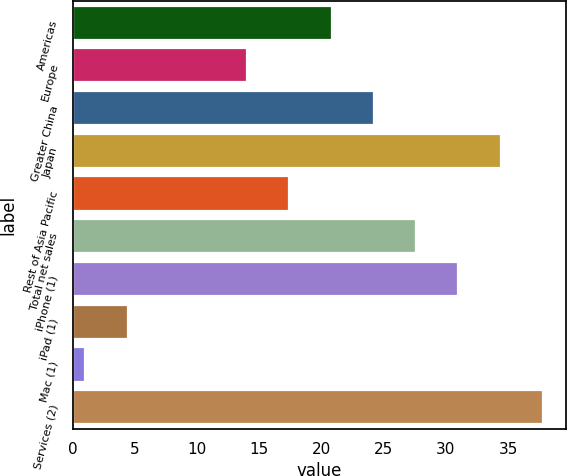Convert chart. <chart><loc_0><loc_0><loc_500><loc_500><bar_chart><fcel>Americas<fcel>Europe<fcel>Greater China<fcel>Japan<fcel>Rest of Asia Pacific<fcel>Total net sales<fcel>iPhone (1)<fcel>iPad (1)<fcel>Mac (1)<fcel>Services (2)<nl><fcel>20.8<fcel>14<fcel>24.2<fcel>34.4<fcel>17.4<fcel>27.6<fcel>31<fcel>4.4<fcel>1<fcel>37.8<nl></chart> 